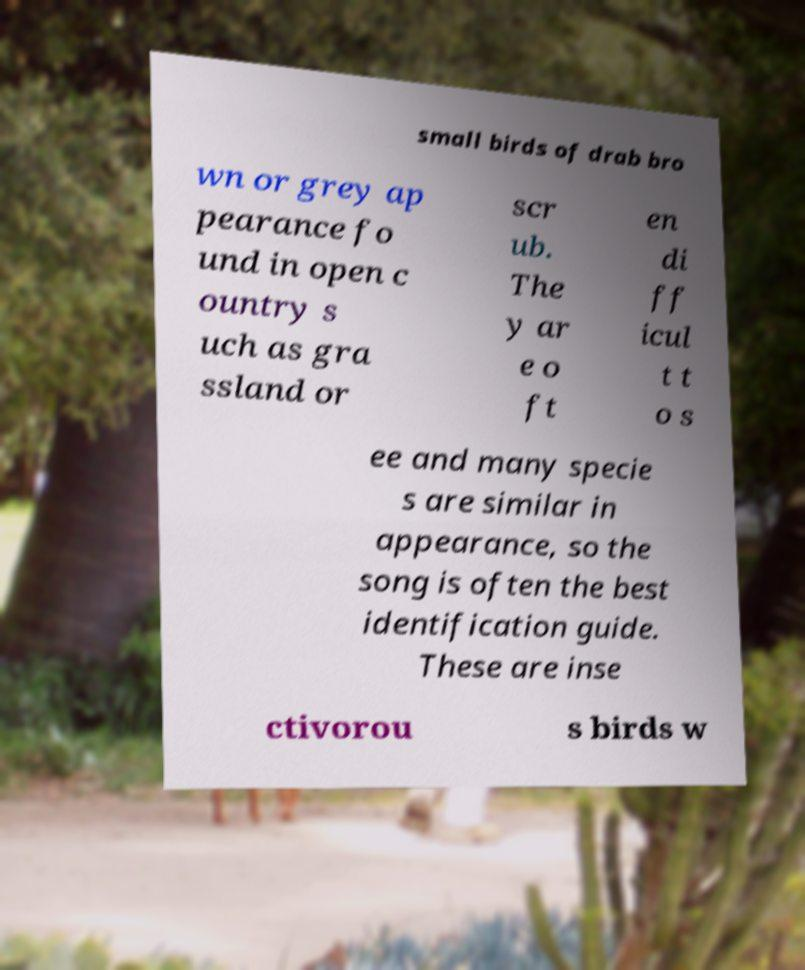What messages or text are displayed in this image? I need them in a readable, typed format. small birds of drab bro wn or grey ap pearance fo und in open c ountry s uch as gra ssland or scr ub. The y ar e o ft en di ff icul t t o s ee and many specie s are similar in appearance, so the song is often the best identification guide. These are inse ctivorou s birds w 